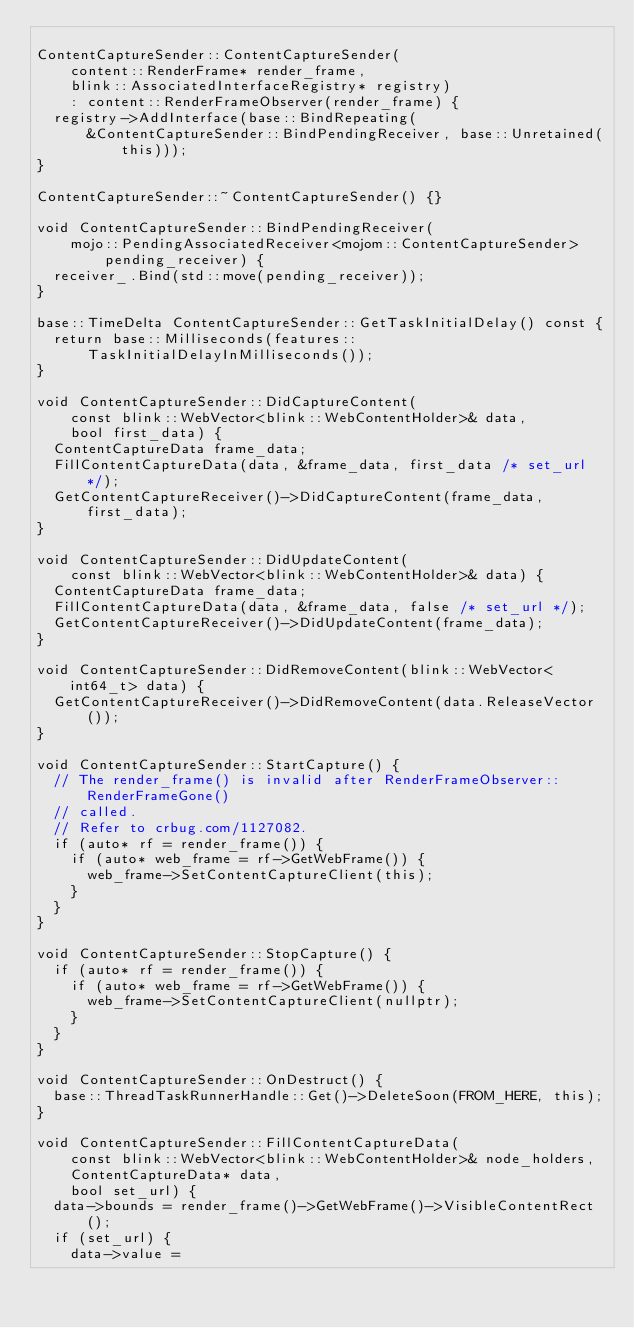Convert code to text. <code><loc_0><loc_0><loc_500><loc_500><_C++_>
ContentCaptureSender::ContentCaptureSender(
    content::RenderFrame* render_frame,
    blink::AssociatedInterfaceRegistry* registry)
    : content::RenderFrameObserver(render_frame) {
  registry->AddInterface(base::BindRepeating(
      &ContentCaptureSender::BindPendingReceiver, base::Unretained(this)));
}

ContentCaptureSender::~ContentCaptureSender() {}

void ContentCaptureSender::BindPendingReceiver(
    mojo::PendingAssociatedReceiver<mojom::ContentCaptureSender>
        pending_receiver) {
  receiver_.Bind(std::move(pending_receiver));
}

base::TimeDelta ContentCaptureSender::GetTaskInitialDelay() const {
  return base::Milliseconds(features::TaskInitialDelayInMilliseconds());
}

void ContentCaptureSender::DidCaptureContent(
    const blink::WebVector<blink::WebContentHolder>& data,
    bool first_data) {
  ContentCaptureData frame_data;
  FillContentCaptureData(data, &frame_data, first_data /* set_url */);
  GetContentCaptureReceiver()->DidCaptureContent(frame_data, first_data);
}

void ContentCaptureSender::DidUpdateContent(
    const blink::WebVector<blink::WebContentHolder>& data) {
  ContentCaptureData frame_data;
  FillContentCaptureData(data, &frame_data, false /* set_url */);
  GetContentCaptureReceiver()->DidUpdateContent(frame_data);
}

void ContentCaptureSender::DidRemoveContent(blink::WebVector<int64_t> data) {
  GetContentCaptureReceiver()->DidRemoveContent(data.ReleaseVector());
}

void ContentCaptureSender::StartCapture() {
  // The render_frame() is invalid after RenderFrameObserver::RenderFrameGone()
  // called.
  // Refer to crbug.com/1127082.
  if (auto* rf = render_frame()) {
    if (auto* web_frame = rf->GetWebFrame()) {
      web_frame->SetContentCaptureClient(this);
    }
  }
}

void ContentCaptureSender::StopCapture() {
  if (auto* rf = render_frame()) {
    if (auto* web_frame = rf->GetWebFrame()) {
      web_frame->SetContentCaptureClient(nullptr);
    }
  }
}

void ContentCaptureSender::OnDestruct() {
  base::ThreadTaskRunnerHandle::Get()->DeleteSoon(FROM_HERE, this);
}

void ContentCaptureSender::FillContentCaptureData(
    const blink::WebVector<blink::WebContentHolder>& node_holders,
    ContentCaptureData* data,
    bool set_url) {
  data->bounds = render_frame()->GetWebFrame()->VisibleContentRect();
  if (set_url) {
    data->value =</code> 